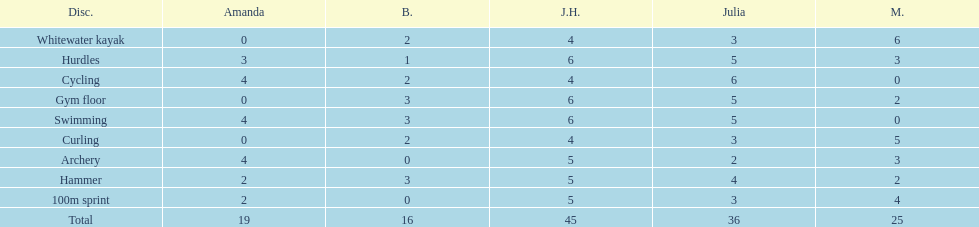What is the last discipline listed on this chart? 100m sprint. Could you parse the entire table as a dict? {'header': ['Disc.', 'Amanda', 'B.', 'J.H.', 'Julia', 'M.'], 'rows': [['Whitewater kayak', '0', '2', '4', '3', '6'], ['Hurdles', '3', '1', '6', '5', '3'], ['Cycling', '4', '2', '4', '6', '0'], ['Gym floor', '0', '3', '6', '5', '2'], ['Swimming', '4', '3', '6', '5', '0'], ['Curling', '0', '2', '4', '3', '5'], ['Archery', '4', '0', '5', '2', '3'], ['Hammer', '2', '3', '5', '4', '2'], ['100m sprint', '2', '0', '5', '3', '4'], ['Total', '19', '16', '45', '36', '25']]} 